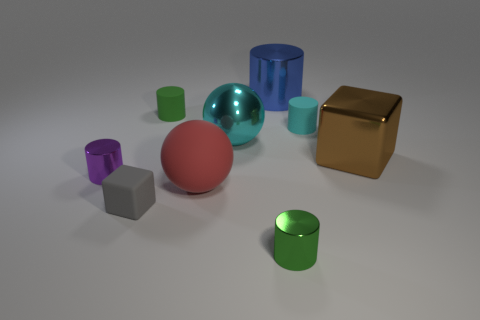Subtract all green metal cylinders. How many cylinders are left? 4 Subtract all blue cylinders. How many cylinders are left? 4 Subtract 1 cylinders. How many cylinders are left? 4 Subtract all brown cylinders. Subtract all blue balls. How many cylinders are left? 5 Add 1 red balls. How many objects exist? 10 Subtract all cylinders. How many objects are left? 4 Add 3 green matte cylinders. How many green matte cylinders are left? 4 Add 5 large gray rubber cylinders. How many large gray rubber cylinders exist? 5 Subtract 0 blue balls. How many objects are left? 9 Subtract all small brown spheres. Subtract all green metal objects. How many objects are left? 8 